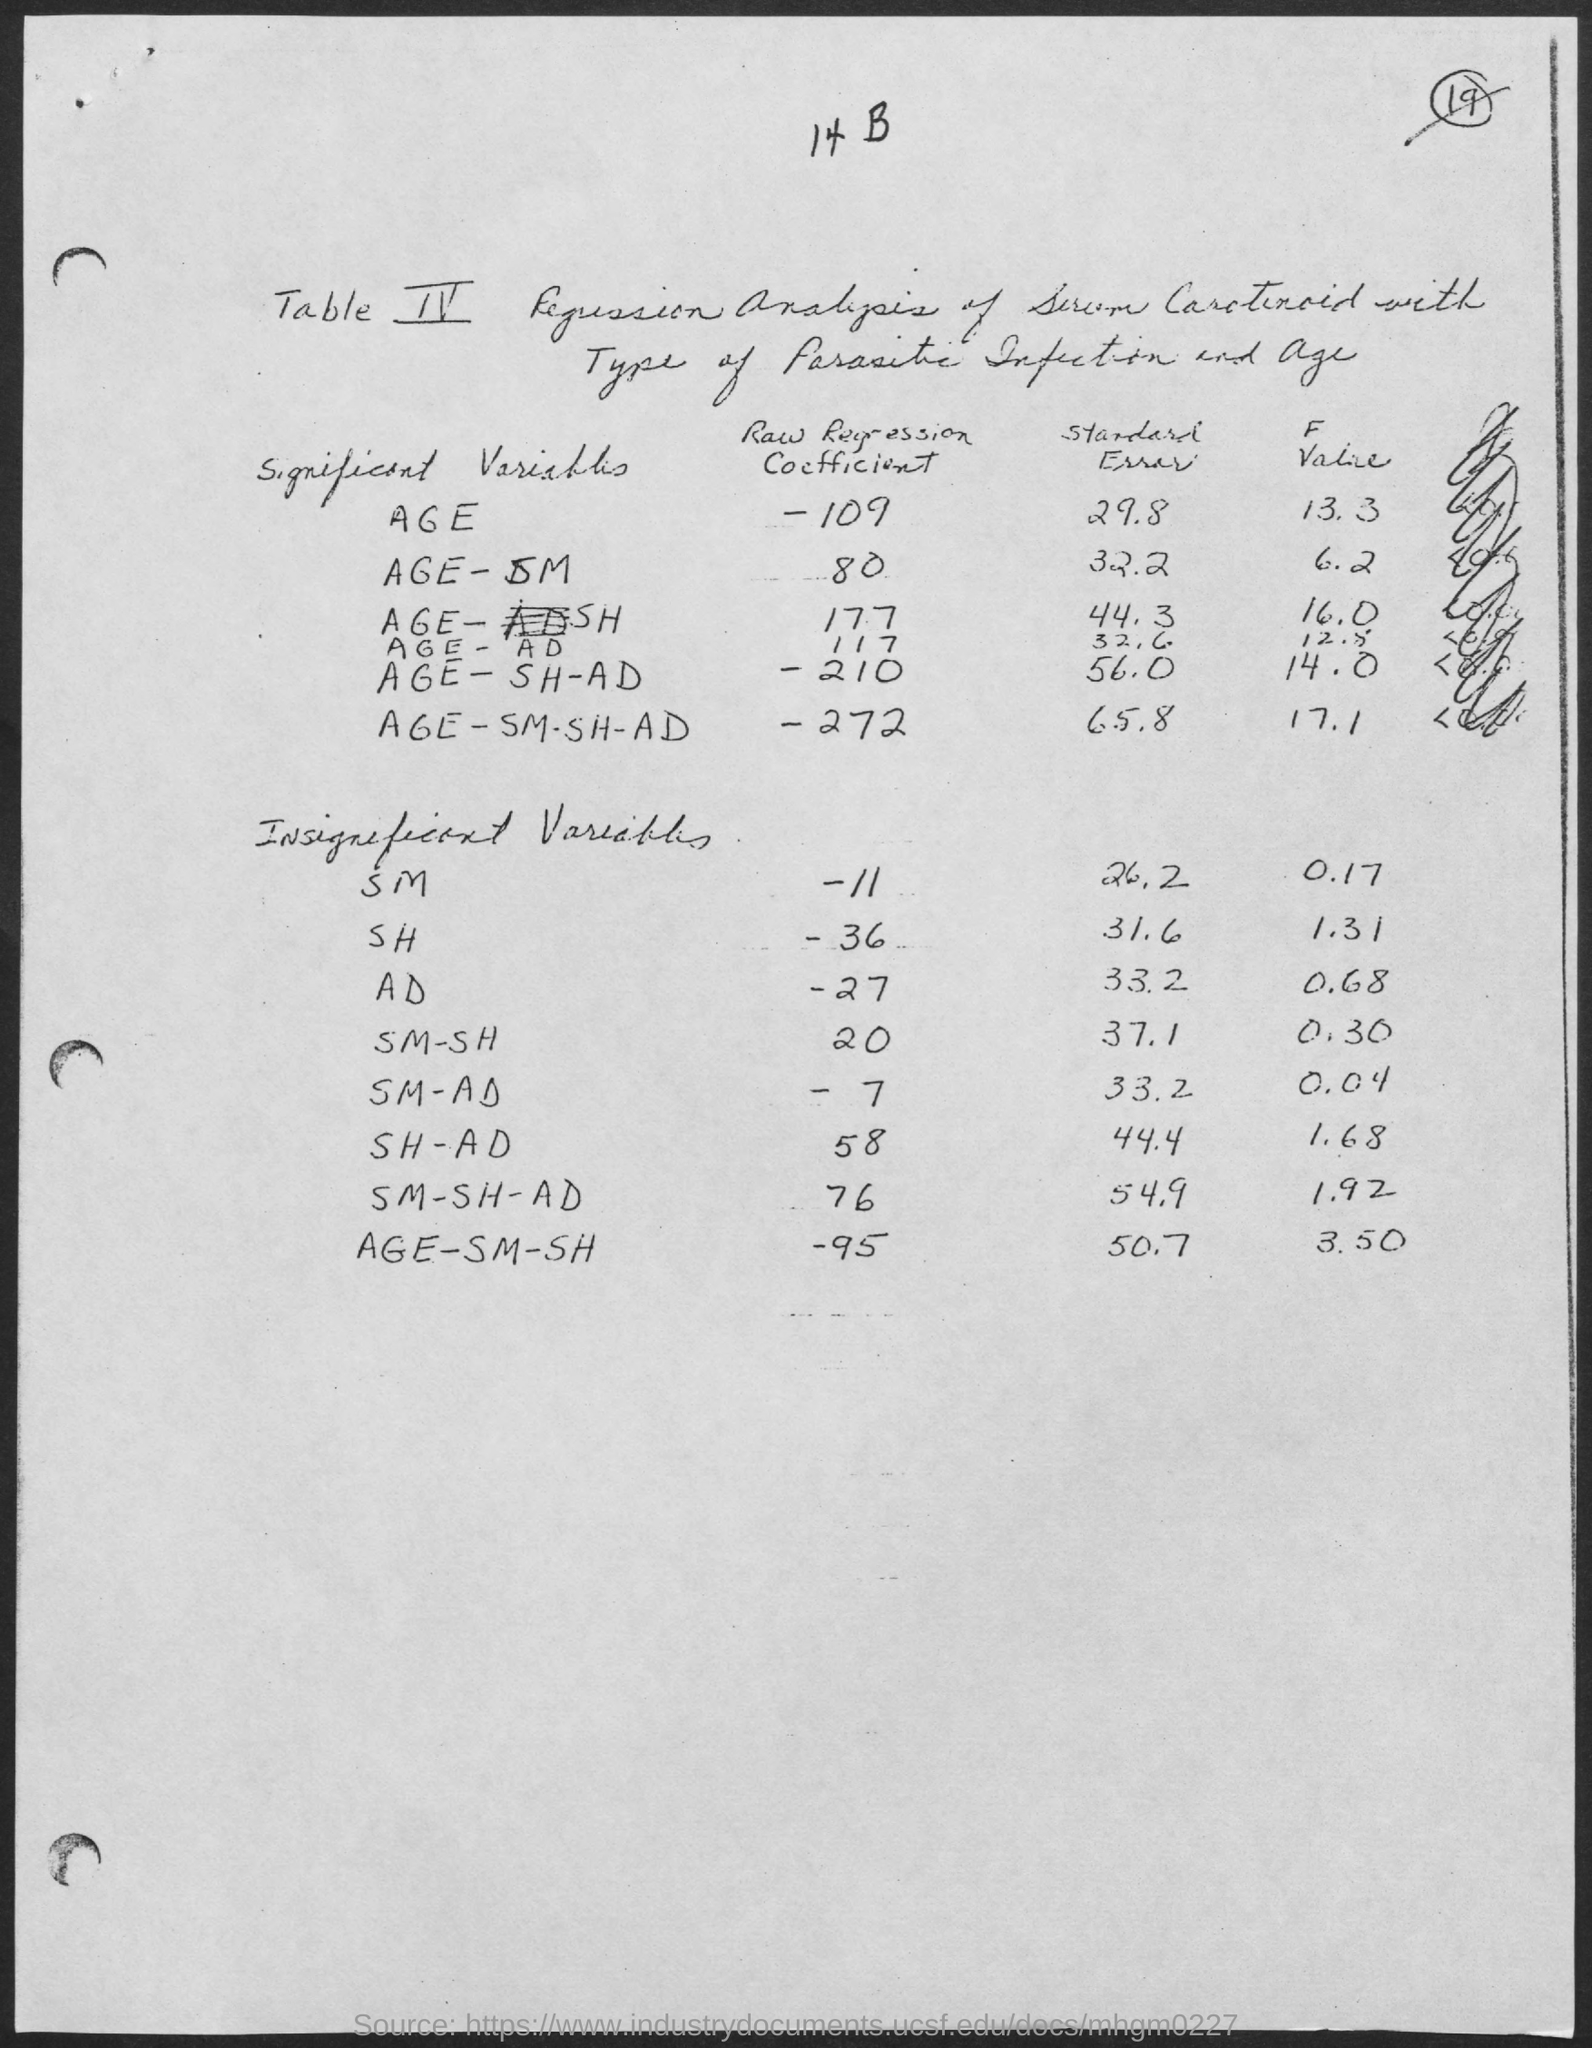Specify some key components in this picture. The standard error for age-AD is 32.6. The regression coefficient for the relationship between age and SM when controlling for other factors is 80. The standard error for age is 29.8 years. The raw regression coefficient for age-SHT is 177, which indicates a strong positive relationship between age and SHT. The standard error for Age-SH is 44.3. 